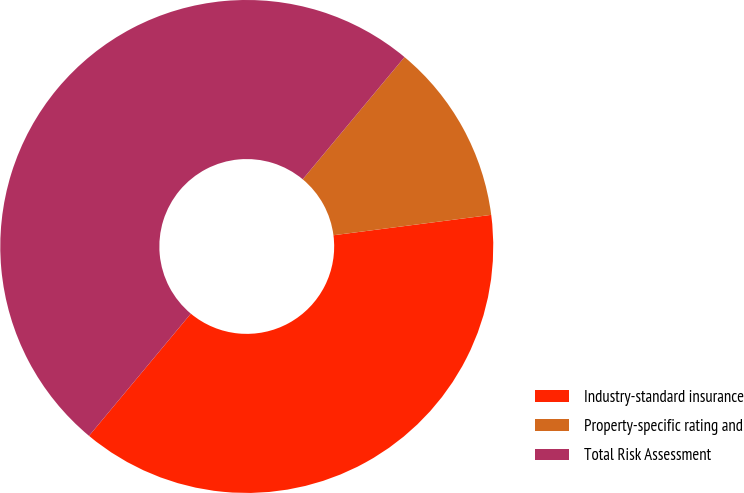<chart> <loc_0><loc_0><loc_500><loc_500><pie_chart><fcel>Industry-standard insurance<fcel>Property-specific rating and<fcel>Total Risk Assessment<nl><fcel>38.1%<fcel>11.9%<fcel>50.0%<nl></chart> 